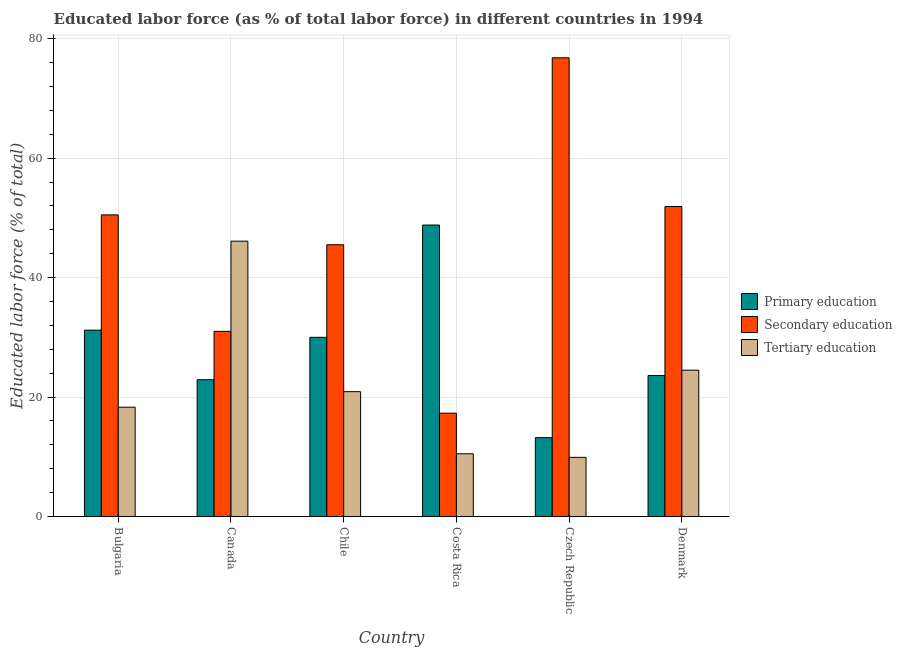How many groups of bars are there?
Your answer should be very brief. 6. Are the number of bars on each tick of the X-axis equal?
Provide a succinct answer. Yes. How many bars are there on the 6th tick from the left?
Provide a short and direct response. 3. How many bars are there on the 4th tick from the right?
Give a very brief answer. 3. What is the label of the 5th group of bars from the left?
Your answer should be compact. Czech Republic. What is the percentage of labor force who received secondary education in Bulgaria?
Provide a short and direct response. 50.5. Across all countries, what is the maximum percentage of labor force who received secondary education?
Your answer should be compact. 76.8. Across all countries, what is the minimum percentage of labor force who received primary education?
Your answer should be compact. 13.2. In which country was the percentage of labor force who received tertiary education maximum?
Offer a terse response. Canada. In which country was the percentage of labor force who received primary education minimum?
Offer a very short reply. Czech Republic. What is the total percentage of labor force who received primary education in the graph?
Give a very brief answer. 169.7. What is the difference between the percentage of labor force who received secondary education in Czech Republic and that in Denmark?
Your response must be concise. 24.9. What is the difference between the percentage of labor force who received tertiary education in Costa Rica and the percentage of labor force who received primary education in Czech Republic?
Offer a terse response. -2.7. What is the average percentage of labor force who received secondary education per country?
Your response must be concise. 45.5. What is the difference between the percentage of labor force who received secondary education and percentage of labor force who received tertiary education in Costa Rica?
Give a very brief answer. 6.8. What is the ratio of the percentage of labor force who received tertiary education in Bulgaria to that in Czech Republic?
Your answer should be very brief. 1.85. What is the difference between the highest and the second highest percentage of labor force who received primary education?
Your answer should be compact. 17.6. What is the difference between the highest and the lowest percentage of labor force who received primary education?
Your answer should be very brief. 35.6. What does the 1st bar from the right in Canada represents?
Your answer should be compact. Tertiary education. Is it the case that in every country, the sum of the percentage of labor force who received primary education and percentage of labor force who received secondary education is greater than the percentage of labor force who received tertiary education?
Provide a succinct answer. Yes. How many bars are there?
Keep it short and to the point. 18. What is the difference between two consecutive major ticks on the Y-axis?
Give a very brief answer. 20. Where does the legend appear in the graph?
Make the answer very short. Center right. What is the title of the graph?
Provide a succinct answer. Educated labor force (as % of total labor force) in different countries in 1994. Does "Tertiary" appear as one of the legend labels in the graph?
Give a very brief answer. No. What is the label or title of the X-axis?
Offer a terse response. Country. What is the label or title of the Y-axis?
Offer a very short reply. Educated labor force (% of total). What is the Educated labor force (% of total) of Primary education in Bulgaria?
Provide a short and direct response. 31.2. What is the Educated labor force (% of total) in Secondary education in Bulgaria?
Your response must be concise. 50.5. What is the Educated labor force (% of total) in Tertiary education in Bulgaria?
Offer a terse response. 18.3. What is the Educated labor force (% of total) of Primary education in Canada?
Your answer should be compact. 22.9. What is the Educated labor force (% of total) of Secondary education in Canada?
Keep it short and to the point. 31. What is the Educated labor force (% of total) in Tertiary education in Canada?
Provide a short and direct response. 46.1. What is the Educated labor force (% of total) of Secondary education in Chile?
Make the answer very short. 45.5. What is the Educated labor force (% of total) of Tertiary education in Chile?
Offer a very short reply. 20.9. What is the Educated labor force (% of total) of Primary education in Costa Rica?
Provide a short and direct response. 48.8. What is the Educated labor force (% of total) of Secondary education in Costa Rica?
Provide a short and direct response. 17.3. What is the Educated labor force (% of total) in Primary education in Czech Republic?
Your response must be concise. 13.2. What is the Educated labor force (% of total) of Secondary education in Czech Republic?
Make the answer very short. 76.8. What is the Educated labor force (% of total) of Tertiary education in Czech Republic?
Give a very brief answer. 9.9. What is the Educated labor force (% of total) of Primary education in Denmark?
Ensure brevity in your answer.  23.6. What is the Educated labor force (% of total) of Secondary education in Denmark?
Ensure brevity in your answer.  51.9. Across all countries, what is the maximum Educated labor force (% of total) in Primary education?
Offer a terse response. 48.8. Across all countries, what is the maximum Educated labor force (% of total) of Secondary education?
Your response must be concise. 76.8. Across all countries, what is the maximum Educated labor force (% of total) of Tertiary education?
Your response must be concise. 46.1. Across all countries, what is the minimum Educated labor force (% of total) of Primary education?
Keep it short and to the point. 13.2. Across all countries, what is the minimum Educated labor force (% of total) of Secondary education?
Your response must be concise. 17.3. Across all countries, what is the minimum Educated labor force (% of total) of Tertiary education?
Your response must be concise. 9.9. What is the total Educated labor force (% of total) of Primary education in the graph?
Your answer should be very brief. 169.7. What is the total Educated labor force (% of total) in Secondary education in the graph?
Your answer should be very brief. 273. What is the total Educated labor force (% of total) in Tertiary education in the graph?
Provide a succinct answer. 130.2. What is the difference between the Educated labor force (% of total) in Secondary education in Bulgaria and that in Canada?
Provide a short and direct response. 19.5. What is the difference between the Educated labor force (% of total) of Tertiary education in Bulgaria and that in Canada?
Your answer should be very brief. -27.8. What is the difference between the Educated labor force (% of total) of Secondary education in Bulgaria and that in Chile?
Provide a succinct answer. 5. What is the difference between the Educated labor force (% of total) in Tertiary education in Bulgaria and that in Chile?
Make the answer very short. -2.6. What is the difference between the Educated labor force (% of total) in Primary education in Bulgaria and that in Costa Rica?
Ensure brevity in your answer.  -17.6. What is the difference between the Educated labor force (% of total) of Secondary education in Bulgaria and that in Costa Rica?
Provide a succinct answer. 33.2. What is the difference between the Educated labor force (% of total) in Tertiary education in Bulgaria and that in Costa Rica?
Give a very brief answer. 7.8. What is the difference between the Educated labor force (% of total) of Primary education in Bulgaria and that in Czech Republic?
Offer a terse response. 18. What is the difference between the Educated labor force (% of total) in Secondary education in Bulgaria and that in Czech Republic?
Provide a succinct answer. -26.3. What is the difference between the Educated labor force (% of total) in Secondary education in Bulgaria and that in Denmark?
Keep it short and to the point. -1.4. What is the difference between the Educated labor force (% of total) of Secondary education in Canada and that in Chile?
Ensure brevity in your answer.  -14.5. What is the difference between the Educated labor force (% of total) in Tertiary education in Canada and that in Chile?
Offer a very short reply. 25.2. What is the difference between the Educated labor force (% of total) of Primary education in Canada and that in Costa Rica?
Give a very brief answer. -25.9. What is the difference between the Educated labor force (% of total) in Secondary education in Canada and that in Costa Rica?
Give a very brief answer. 13.7. What is the difference between the Educated labor force (% of total) in Tertiary education in Canada and that in Costa Rica?
Offer a terse response. 35.6. What is the difference between the Educated labor force (% of total) in Secondary education in Canada and that in Czech Republic?
Your answer should be compact. -45.8. What is the difference between the Educated labor force (% of total) in Tertiary education in Canada and that in Czech Republic?
Give a very brief answer. 36.2. What is the difference between the Educated labor force (% of total) of Primary education in Canada and that in Denmark?
Provide a short and direct response. -0.7. What is the difference between the Educated labor force (% of total) of Secondary education in Canada and that in Denmark?
Provide a short and direct response. -20.9. What is the difference between the Educated labor force (% of total) of Tertiary education in Canada and that in Denmark?
Offer a very short reply. 21.6. What is the difference between the Educated labor force (% of total) of Primary education in Chile and that in Costa Rica?
Offer a terse response. -18.8. What is the difference between the Educated labor force (% of total) in Secondary education in Chile and that in Costa Rica?
Your response must be concise. 28.2. What is the difference between the Educated labor force (% of total) of Tertiary education in Chile and that in Costa Rica?
Provide a succinct answer. 10.4. What is the difference between the Educated labor force (% of total) of Primary education in Chile and that in Czech Republic?
Your answer should be very brief. 16.8. What is the difference between the Educated labor force (% of total) of Secondary education in Chile and that in Czech Republic?
Provide a succinct answer. -31.3. What is the difference between the Educated labor force (% of total) of Tertiary education in Chile and that in Denmark?
Provide a short and direct response. -3.6. What is the difference between the Educated labor force (% of total) in Primary education in Costa Rica and that in Czech Republic?
Your response must be concise. 35.6. What is the difference between the Educated labor force (% of total) of Secondary education in Costa Rica and that in Czech Republic?
Make the answer very short. -59.5. What is the difference between the Educated labor force (% of total) in Tertiary education in Costa Rica and that in Czech Republic?
Keep it short and to the point. 0.6. What is the difference between the Educated labor force (% of total) in Primary education in Costa Rica and that in Denmark?
Provide a succinct answer. 25.2. What is the difference between the Educated labor force (% of total) of Secondary education in Costa Rica and that in Denmark?
Provide a succinct answer. -34.6. What is the difference between the Educated labor force (% of total) of Tertiary education in Costa Rica and that in Denmark?
Offer a terse response. -14. What is the difference between the Educated labor force (% of total) of Secondary education in Czech Republic and that in Denmark?
Your answer should be very brief. 24.9. What is the difference between the Educated labor force (% of total) in Tertiary education in Czech Republic and that in Denmark?
Your answer should be very brief. -14.6. What is the difference between the Educated labor force (% of total) in Primary education in Bulgaria and the Educated labor force (% of total) in Secondary education in Canada?
Offer a terse response. 0.2. What is the difference between the Educated labor force (% of total) in Primary education in Bulgaria and the Educated labor force (% of total) in Tertiary education in Canada?
Keep it short and to the point. -14.9. What is the difference between the Educated labor force (% of total) of Primary education in Bulgaria and the Educated labor force (% of total) of Secondary education in Chile?
Your answer should be compact. -14.3. What is the difference between the Educated labor force (% of total) of Secondary education in Bulgaria and the Educated labor force (% of total) of Tertiary education in Chile?
Your answer should be compact. 29.6. What is the difference between the Educated labor force (% of total) of Primary education in Bulgaria and the Educated labor force (% of total) of Tertiary education in Costa Rica?
Provide a short and direct response. 20.7. What is the difference between the Educated labor force (% of total) of Primary education in Bulgaria and the Educated labor force (% of total) of Secondary education in Czech Republic?
Offer a terse response. -45.6. What is the difference between the Educated labor force (% of total) in Primary education in Bulgaria and the Educated labor force (% of total) in Tertiary education in Czech Republic?
Give a very brief answer. 21.3. What is the difference between the Educated labor force (% of total) in Secondary education in Bulgaria and the Educated labor force (% of total) in Tertiary education in Czech Republic?
Provide a succinct answer. 40.6. What is the difference between the Educated labor force (% of total) in Primary education in Bulgaria and the Educated labor force (% of total) in Secondary education in Denmark?
Provide a succinct answer. -20.7. What is the difference between the Educated labor force (% of total) of Secondary education in Bulgaria and the Educated labor force (% of total) of Tertiary education in Denmark?
Ensure brevity in your answer.  26. What is the difference between the Educated labor force (% of total) in Primary education in Canada and the Educated labor force (% of total) in Secondary education in Chile?
Give a very brief answer. -22.6. What is the difference between the Educated labor force (% of total) of Primary education in Canada and the Educated labor force (% of total) of Tertiary education in Costa Rica?
Provide a short and direct response. 12.4. What is the difference between the Educated labor force (% of total) in Secondary education in Canada and the Educated labor force (% of total) in Tertiary education in Costa Rica?
Keep it short and to the point. 20.5. What is the difference between the Educated labor force (% of total) of Primary education in Canada and the Educated labor force (% of total) of Secondary education in Czech Republic?
Your response must be concise. -53.9. What is the difference between the Educated labor force (% of total) in Primary education in Canada and the Educated labor force (% of total) in Tertiary education in Czech Republic?
Your answer should be very brief. 13. What is the difference between the Educated labor force (% of total) of Secondary education in Canada and the Educated labor force (% of total) of Tertiary education in Czech Republic?
Provide a succinct answer. 21.1. What is the difference between the Educated labor force (% of total) of Primary education in Chile and the Educated labor force (% of total) of Tertiary education in Costa Rica?
Ensure brevity in your answer.  19.5. What is the difference between the Educated labor force (% of total) of Primary education in Chile and the Educated labor force (% of total) of Secondary education in Czech Republic?
Offer a very short reply. -46.8. What is the difference between the Educated labor force (% of total) of Primary education in Chile and the Educated labor force (% of total) of Tertiary education in Czech Republic?
Keep it short and to the point. 20.1. What is the difference between the Educated labor force (% of total) in Secondary education in Chile and the Educated labor force (% of total) in Tertiary education in Czech Republic?
Offer a terse response. 35.6. What is the difference between the Educated labor force (% of total) in Primary education in Chile and the Educated labor force (% of total) in Secondary education in Denmark?
Ensure brevity in your answer.  -21.9. What is the difference between the Educated labor force (% of total) in Primary education in Chile and the Educated labor force (% of total) in Tertiary education in Denmark?
Keep it short and to the point. 5.5. What is the difference between the Educated labor force (% of total) of Secondary education in Chile and the Educated labor force (% of total) of Tertiary education in Denmark?
Make the answer very short. 21. What is the difference between the Educated labor force (% of total) of Primary education in Costa Rica and the Educated labor force (% of total) of Tertiary education in Czech Republic?
Offer a terse response. 38.9. What is the difference between the Educated labor force (% of total) of Primary education in Costa Rica and the Educated labor force (% of total) of Tertiary education in Denmark?
Your answer should be compact. 24.3. What is the difference between the Educated labor force (% of total) in Primary education in Czech Republic and the Educated labor force (% of total) in Secondary education in Denmark?
Ensure brevity in your answer.  -38.7. What is the difference between the Educated labor force (% of total) of Secondary education in Czech Republic and the Educated labor force (% of total) of Tertiary education in Denmark?
Provide a succinct answer. 52.3. What is the average Educated labor force (% of total) of Primary education per country?
Keep it short and to the point. 28.28. What is the average Educated labor force (% of total) of Secondary education per country?
Give a very brief answer. 45.5. What is the average Educated labor force (% of total) in Tertiary education per country?
Offer a terse response. 21.7. What is the difference between the Educated labor force (% of total) in Primary education and Educated labor force (% of total) in Secondary education in Bulgaria?
Keep it short and to the point. -19.3. What is the difference between the Educated labor force (% of total) of Secondary education and Educated labor force (% of total) of Tertiary education in Bulgaria?
Your answer should be compact. 32.2. What is the difference between the Educated labor force (% of total) of Primary education and Educated labor force (% of total) of Tertiary education in Canada?
Make the answer very short. -23.2. What is the difference between the Educated labor force (% of total) in Secondary education and Educated labor force (% of total) in Tertiary education in Canada?
Provide a succinct answer. -15.1. What is the difference between the Educated labor force (% of total) in Primary education and Educated labor force (% of total) in Secondary education in Chile?
Provide a short and direct response. -15.5. What is the difference between the Educated labor force (% of total) of Secondary education and Educated labor force (% of total) of Tertiary education in Chile?
Keep it short and to the point. 24.6. What is the difference between the Educated labor force (% of total) of Primary education and Educated labor force (% of total) of Secondary education in Costa Rica?
Provide a succinct answer. 31.5. What is the difference between the Educated labor force (% of total) in Primary education and Educated labor force (% of total) in Tertiary education in Costa Rica?
Give a very brief answer. 38.3. What is the difference between the Educated labor force (% of total) of Secondary education and Educated labor force (% of total) of Tertiary education in Costa Rica?
Offer a terse response. 6.8. What is the difference between the Educated labor force (% of total) of Primary education and Educated labor force (% of total) of Secondary education in Czech Republic?
Your answer should be very brief. -63.6. What is the difference between the Educated labor force (% of total) of Secondary education and Educated labor force (% of total) of Tertiary education in Czech Republic?
Make the answer very short. 66.9. What is the difference between the Educated labor force (% of total) of Primary education and Educated labor force (% of total) of Secondary education in Denmark?
Your answer should be very brief. -28.3. What is the difference between the Educated labor force (% of total) in Secondary education and Educated labor force (% of total) in Tertiary education in Denmark?
Offer a terse response. 27.4. What is the ratio of the Educated labor force (% of total) of Primary education in Bulgaria to that in Canada?
Make the answer very short. 1.36. What is the ratio of the Educated labor force (% of total) of Secondary education in Bulgaria to that in Canada?
Make the answer very short. 1.63. What is the ratio of the Educated labor force (% of total) in Tertiary education in Bulgaria to that in Canada?
Offer a terse response. 0.4. What is the ratio of the Educated labor force (% of total) of Secondary education in Bulgaria to that in Chile?
Give a very brief answer. 1.11. What is the ratio of the Educated labor force (% of total) in Tertiary education in Bulgaria to that in Chile?
Your answer should be compact. 0.88. What is the ratio of the Educated labor force (% of total) of Primary education in Bulgaria to that in Costa Rica?
Your response must be concise. 0.64. What is the ratio of the Educated labor force (% of total) in Secondary education in Bulgaria to that in Costa Rica?
Your response must be concise. 2.92. What is the ratio of the Educated labor force (% of total) in Tertiary education in Bulgaria to that in Costa Rica?
Give a very brief answer. 1.74. What is the ratio of the Educated labor force (% of total) of Primary education in Bulgaria to that in Czech Republic?
Provide a short and direct response. 2.36. What is the ratio of the Educated labor force (% of total) in Secondary education in Bulgaria to that in Czech Republic?
Make the answer very short. 0.66. What is the ratio of the Educated labor force (% of total) in Tertiary education in Bulgaria to that in Czech Republic?
Offer a terse response. 1.85. What is the ratio of the Educated labor force (% of total) in Primary education in Bulgaria to that in Denmark?
Ensure brevity in your answer.  1.32. What is the ratio of the Educated labor force (% of total) in Secondary education in Bulgaria to that in Denmark?
Ensure brevity in your answer.  0.97. What is the ratio of the Educated labor force (% of total) of Tertiary education in Bulgaria to that in Denmark?
Keep it short and to the point. 0.75. What is the ratio of the Educated labor force (% of total) of Primary education in Canada to that in Chile?
Make the answer very short. 0.76. What is the ratio of the Educated labor force (% of total) of Secondary education in Canada to that in Chile?
Ensure brevity in your answer.  0.68. What is the ratio of the Educated labor force (% of total) in Tertiary education in Canada to that in Chile?
Make the answer very short. 2.21. What is the ratio of the Educated labor force (% of total) of Primary education in Canada to that in Costa Rica?
Keep it short and to the point. 0.47. What is the ratio of the Educated labor force (% of total) in Secondary education in Canada to that in Costa Rica?
Your response must be concise. 1.79. What is the ratio of the Educated labor force (% of total) of Tertiary education in Canada to that in Costa Rica?
Keep it short and to the point. 4.39. What is the ratio of the Educated labor force (% of total) of Primary education in Canada to that in Czech Republic?
Offer a very short reply. 1.73. What is the ratio of the Educated labor force (% of total) of Secondary education in Canada to that in Czech Republic?
Make the answer very short. 0.4. What is the ratio of the Educated labor force (% of total) in Tertiary education in Canada to that in Czech Republic?
Your answer should be very brief. 4.66. What is the ratio of the Educated labor force (% of total) of Primary education in Canada to that in Denmark?
Offer a terse response. 0.97. What is the ratio of the Educated labor force (% of total) of Secondary education in Canada to that in Denmark?
Ensure brevity in your answer.  0.6. What is the ratio of the Educated labor force (% of total) of Tertiary education in Canada to that in Denmark?
Offer a terse response. 1.88. What is the ratio of the Educated labor force (% of total) in Primary education in Chile to that in Costa Rica?
Give a very brief answer. 0.61. What is the ratio of the Educated labor force (% of total) of Secondary education in Chile to that in Costa Rica?
Provide a short and direct response. 2.63. What is the ratio of the Educated labor force (% of total) in Tertiary education in Chile to that in Costa Rica?
Your answer should be compact. 1.99. What is the ratio of the Educated labor force (% of total) in Primary education in Chile to that in Czech Republic?
Provide a succinct answer. 2.27. What is the ratio of the Educated labor force (% of total) of Secondary education in Chile to that in Czech Republic?
Give a very brief answer. 0.59. What is the ratio of the Educated labor force (% of total) of Tertiary education in Chile to that in Czech Republic?
Offer a very short reply. 2.11. What is the ratio of the Educated labor force (% of total) in Primary education in Chile to that in Denmark?
Offer a terse response. 1.27. What is the ratio of the Educated labor force (% of total) of Secondary education in Chile to that in Denmark?
Provide a succinct answer. 0.88. What is the ratio of the Educated labor force (% of total) in Tertiary education in Chile to that in Denmark?
Make the answer very short. 0.85. What is the ratio of the Educated labor force (% of total) in Primary education in Costa Rica to that in Czech Republic?
Offer a very short reply. 3.7. What is the ratio of the Educated labor force (% of total) in Secondary education in Costa Rica to that in Czech Republic?
Give a very brief answer. 0.23. What is the ratio of the Educated labor force (% of total) in Tertiary education in Costa Rica to that in Czech Republic?
Make the answer very short. 1.06. What is the ratio of the Educated labor force (% of total) in Primary education in Costa Rica to that in Denmark?
Keep it short and to the point. 2.07. What is the ratio of the Educated labor force (% of total) of Tertiary education in Costa Rica to that in Denmark?
Offer a terse response. 0.43. What is the ratio of the Educated labor force (% of total) in Primary education in Czech Republic to that in Denmark?
Offer a very short reply. 0.56. What is the ratio of the Educated labor force (% of total) in Secondary education in Czech Republic to that in Denmark?
Ensure brevity in your answer.  1.48. What is the ratio of the Educated labor force (% of total) in Tertiary education in Czech Republic to that in Denmark?
Your answer should be compact. 0.4. What is the difference between the highest and the second highest Educated labor force (% of total) in Secondary education?
Make the answer very short. 24.9. What is the difference between the highest and the second highest Educated labor force (% of total) of Tertiary education?
Your answer should be compact. 21.6. What is the difference between the highest and the lowest Educated labor force (% of total) in Primary education?
Give a very brief answer. 35.6. What is the difference between the highest and the lowest Educated labor force (% of total) in Secondary education?
Keep it short and to the point. 59.5. What is the difference between the highest and the lowest Educated labor force (% of total) of Tertiary education?
Keep it short and to the point. 36.2. 